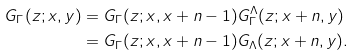<formula> <loc_0><loc_0><loc_500><loc_500>G _ { \Gamma } ( z ; x , y ) & = G _ { \Gamma } ( z ; x , x + n - 1 ) G _ { \Gamma } ^ { \Lambda } ( z ; x + n , y ) \\ & = G _ { \Gamma } ( z ; x , x + n - 1 ) G _ { \Lambda } ( z ; x + n , y ) .</formula> 